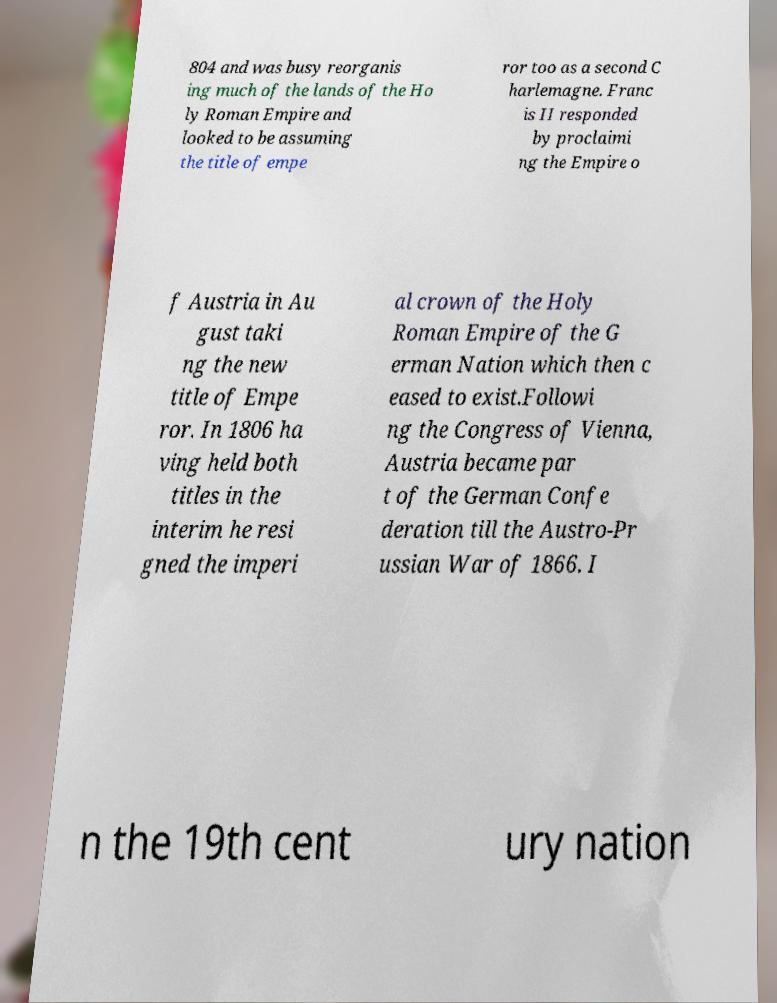For documentation purposes, I need the text within this image transcribed. Could you provide that? 804 and was busy reorganis ing much of the lands of the Ho ly Roman Empire and looked to be assuming the title of empe ror too as a second C harlemagne. Franc is II responded by proclaimi ng the Empire o f Austria in Au gust taki ng the new title of Empe ror. In 1806 ha ving held both titles in the interim he resi gned the imperi al crown of the Holy Roman Empire of the G erman Nation which then c eased to exist.Followi ng the Congress of Vienna, Austria became par t of the German Confe deration till the Austro-Pr ussian War of 1866. I n the 19th cent ury nation 